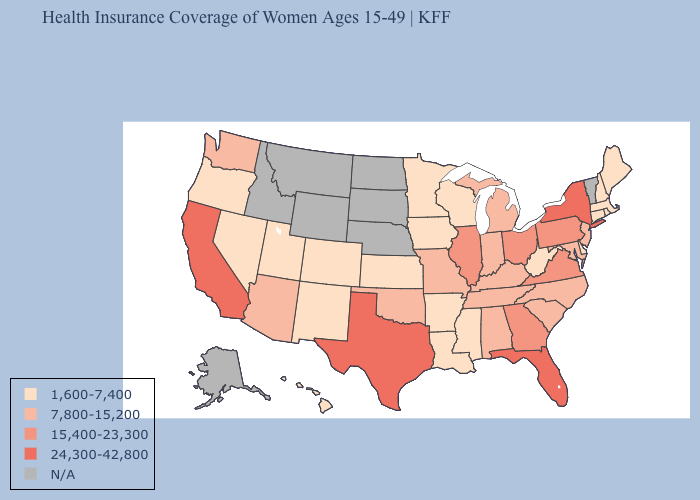What is the highest value in states that border Illinois?
Quick response, please. 7,800-15,200. Among the states that border Oregon , does Nevada have the lowest value?
Keep it brief. Yes. Name the states that have a value in the range 1,600-7,400?
Give a very brief answer. Arkansas, Colorado, Connecticut, Delaware, Hawaii, Iowa, Kansas, Louisiana, Maine, Massachusetts, Minnesota, Mississippi, Nevada, New Hampshire, New Mexico, Oregon, Rhode Island, Utah, West Virginia, Wisconsin. Name the states that have a value in the range 1,600-7,400?
Be succinct. Arkansas, Colorado, Connecticut, Delaware, Hawaii, Iowa, Kansas, Louisiana, Maine, Massachusetts, Minnesota, Mississippi, Nevada, New Hampshire, New Mexico, Oregon, Rhode Island, Utah, West Virginia, Wisconsin. Name the states that have a value in the range 24,300-42,800?
Short answer required. California, Florida, New York, Texas. Does Arkansas have the lowest value in the USA?
Quick response, please. Yes. Does Minnesota have the lowest value in the MidWest?
Concise answer only. Yes. What is the value of Hawaii?
Answer briefly. 1,600-7,400. What is the highest value in the USA?
Answer briefly. 24,300-42,800. What is the value of Kentucky?
Be succinct. 7,800-15,200. What is the value of Colorado?
Answer briefly. 1,600-7,400. Is the legend a continuous bar?
Be succinct. No. What is the lowest value in states that border Delaware?
Give a very brief answer. 7,800-15,200. What is the lowest value in states that border Arizona?
Answer briefly. 1,600-7,400. What is the value of North Dakota?
Keep it brief. N/A. 